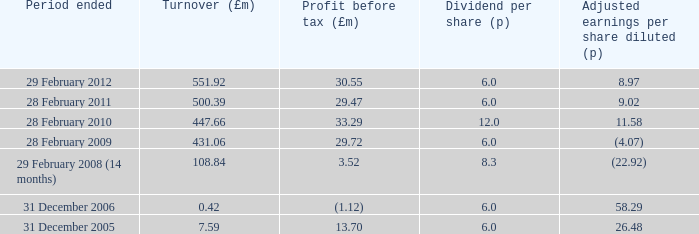Could you parse the entire table as a dict? {'header': ['Period ended', 'Turnover (£m)', 'Profit before tax (£m)', 'Dividend per share (p)', 'Adjusted earnings per share diluted (p)'], 'rows': [['29 February 2012', '551.92', '30.55', '6.0', '8.97'], ['28 February 2011', '500.39', '29.47', '6.0', '9.02'], ['28 February 2010', '447.66', '33.29', '12.0', '11.58'], ['28 February 2009', '431.06', '29.72', '6.0', '(4.07)'], ['29 February 2008 (14 months)', '108.84', '3.52', '8.3', '(22.92)'], ['31 December 2006', '0.42', '(1.12)', '6.0', '58.29'], ['31 December 2005', '7.59', '13.70', '6.0', '26.48']]} What was the income before tax when the sales were 43 29.72. 